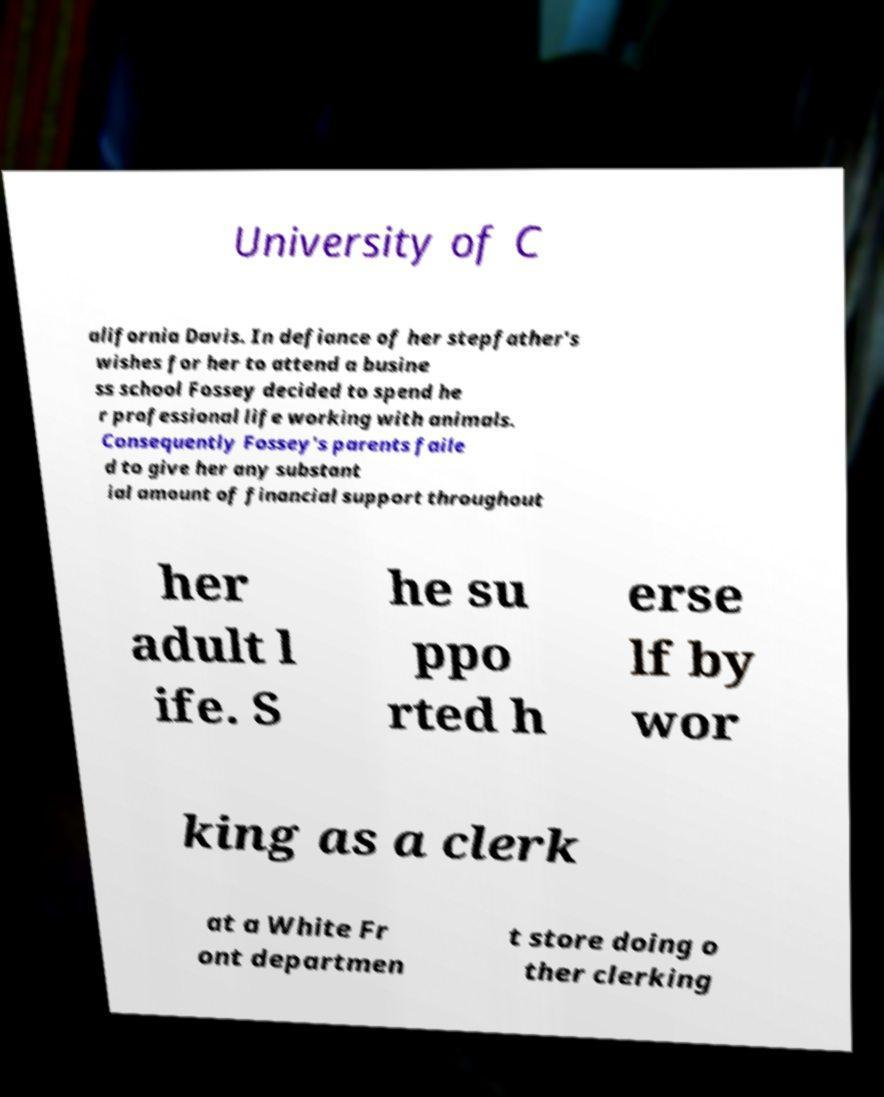I need the written content from this picture converted into text. Can you do that? University of C alifornia Davis. In defiance of her stepfather's wishes for her to attend a busine ss school Fossey decided to spend he r professional life working with animals. Consequently Fossey's parents faile d to give her any substant ial amount of financial support throughout her adult l ife. S he su ppo rted h erse lf by wor king as a clerk at a White Fr ont departmen t store doing o ther clerking 